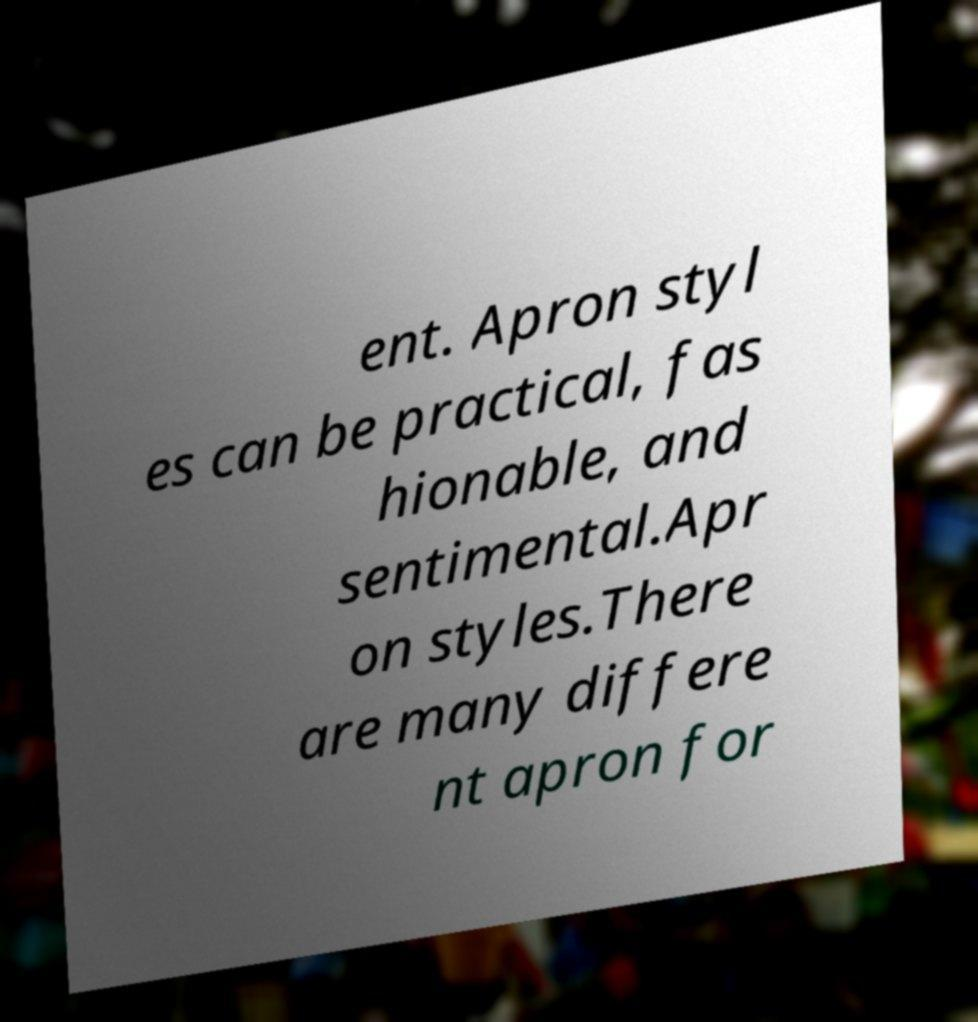Please identify and transcribe the text found in this image. ent. Apron styl es can be practical, fas hionable, and sentimental.Apr on styles.There are many differe nt apron for 